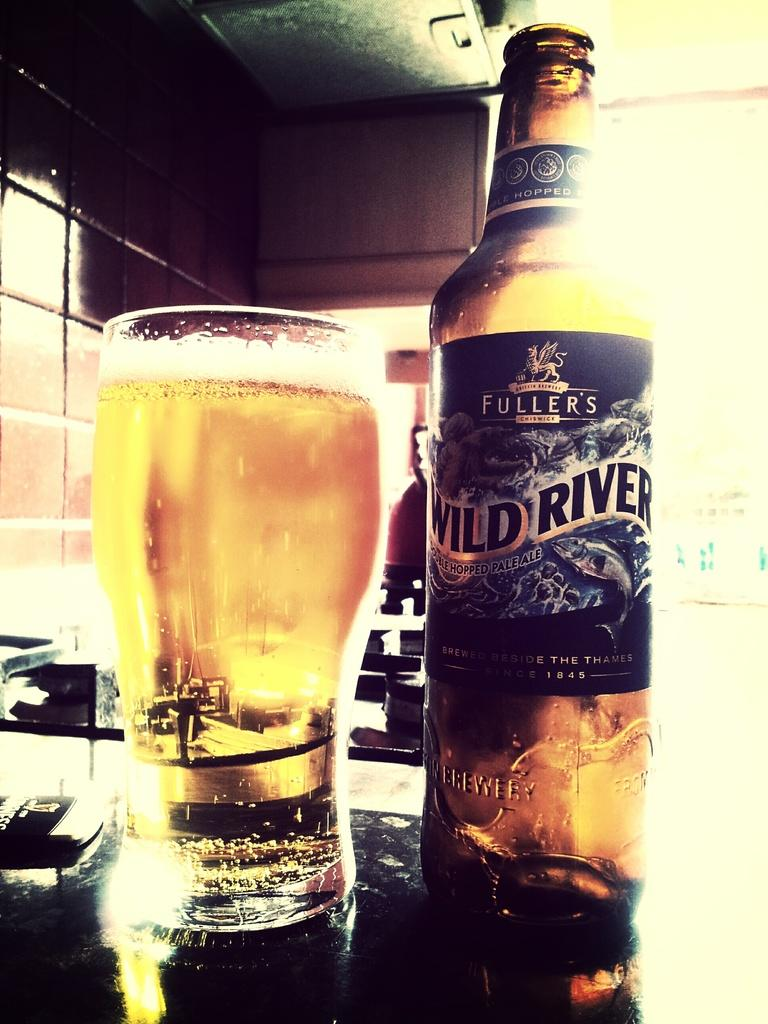<image>
Relay a brief, clear account of the picture shown. A glass of beer next to a bottle that says it is Fuller's brand. 